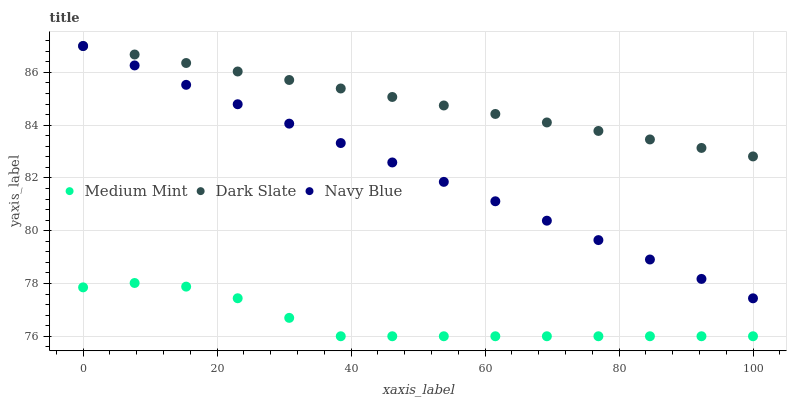Does Medium Mint have the minimum area under the curve?
Answer yes or no. Yes. Does Dark Slate have the maximum area under the curve?
Answer yes or no. Yes. Does Navy Blue have the minimum area under the curve?
Answer yes or no. No. Does Navy Blue have the maximum area under the curve?
Answer yes or no. No. Is Navy Blue the smoothest?
Answer yes or no. Yes. Is Medium Mint the roughest?
Answer yes or no. Yes. Is Dark Slate the smoothest?
Answer yes or no. No. Is Dark Slate the roughest?
Answer yes or no. No. Does Medium Mint have the lowest value?
Answer yes or no. Yes. Does Navy Blue have the lowest value?
Answer yes or no. No. Does Navy Blue have the highest value?
Answer yes or no. Yes. Is Medium Mint less than Dark Slate?
Answer yes or no. Yes. Is Dark Slate greater than Medium Mint?
Answer yes or no. Yes. Does Navy Blue intersect Dark Slate?
Answer yes or no. Yes. Is Navy Blue less than Dark Slate?
Answer yes or no. No. Is Navy Blue greater than Dark Slate?
Answer yes or no. No. Does Medium Mint intersect Dark Slate?
Answer yes or no. No. 